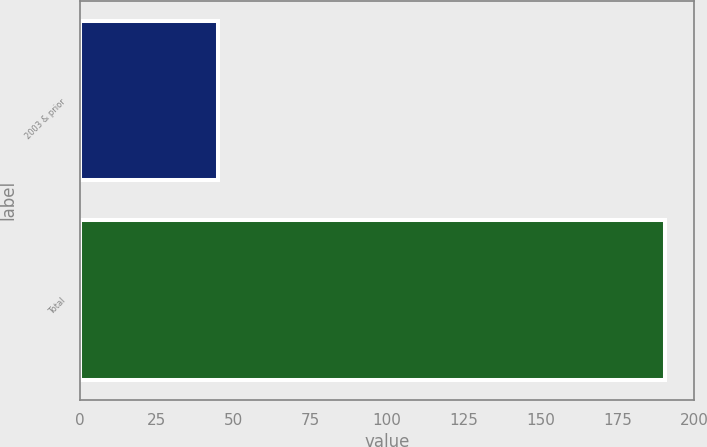<chart> <loc_0><loc_0><loc_500><loc_500><bar_chart><fcel>2003 & prior<fcel>Total<nl><fcel>44.9<fcel>190.5<nl></chart> 